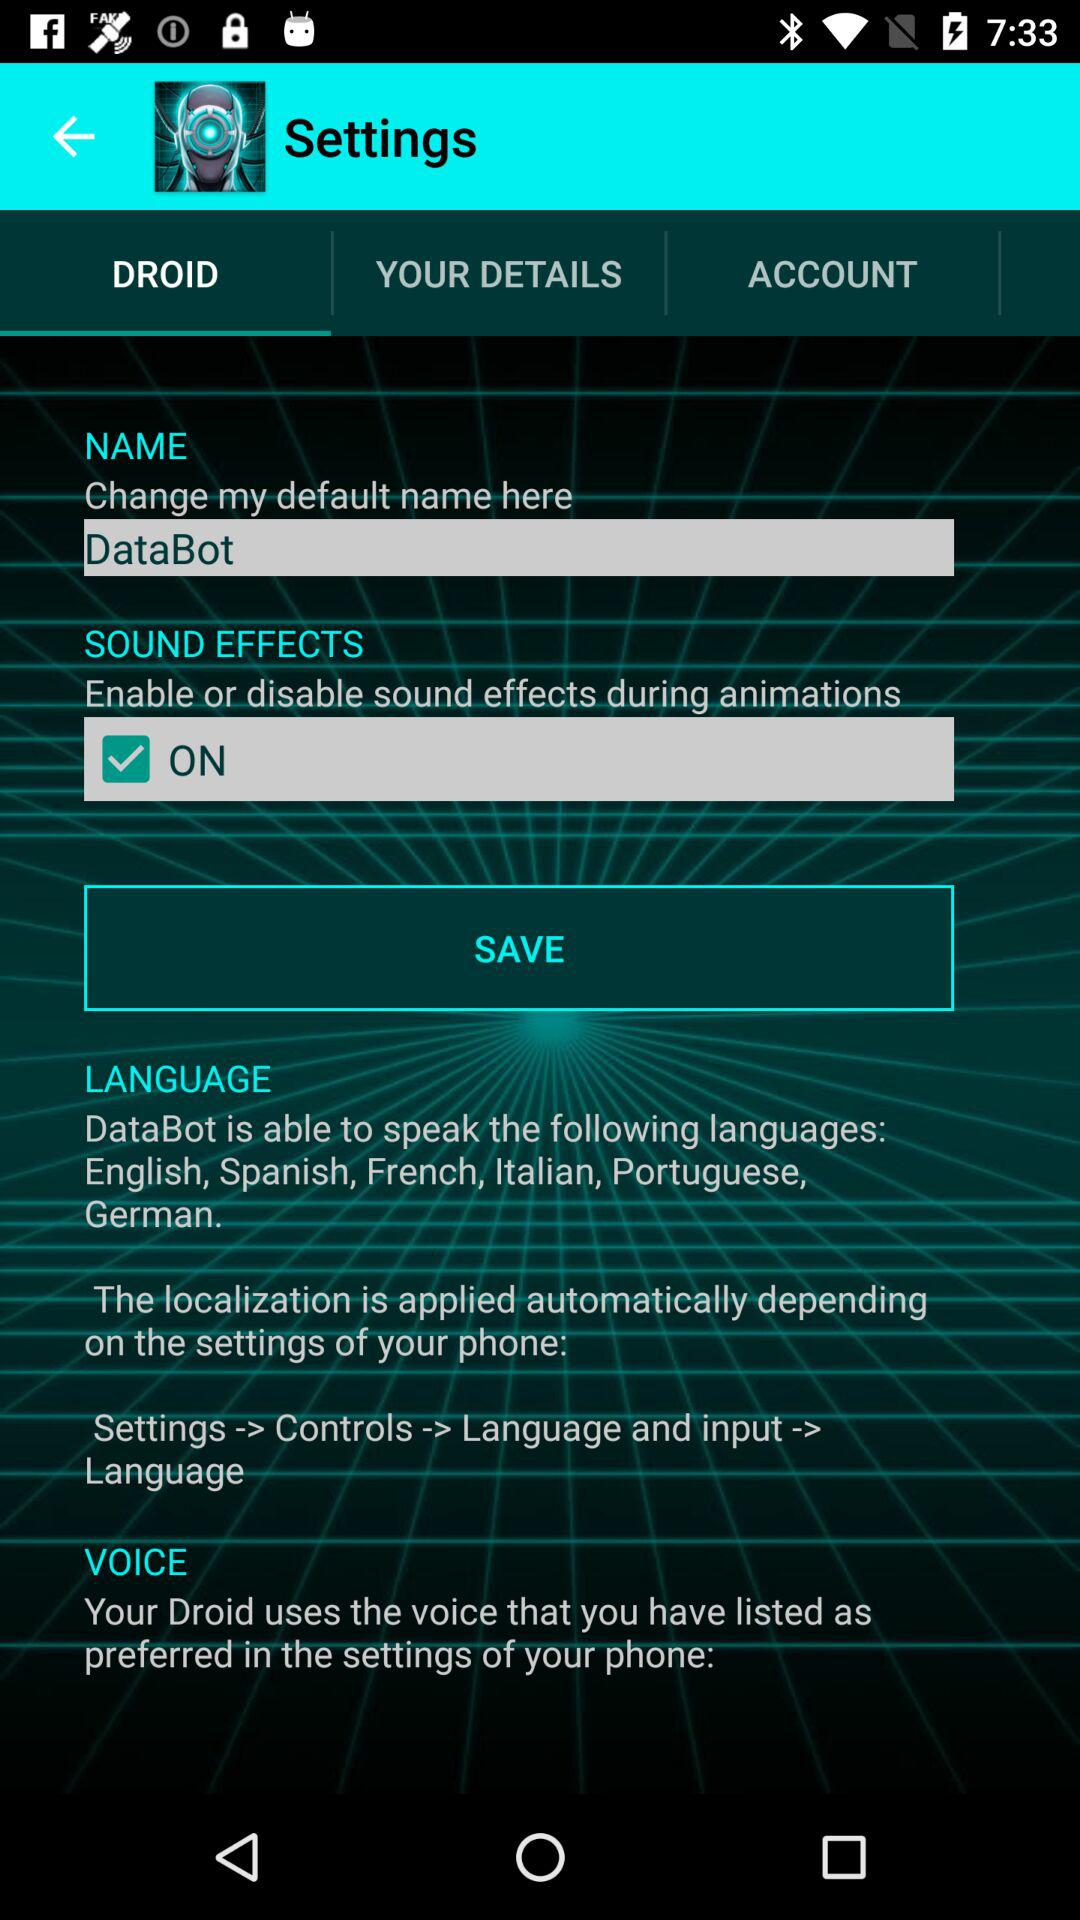What's the username? The username is "DataBot". 